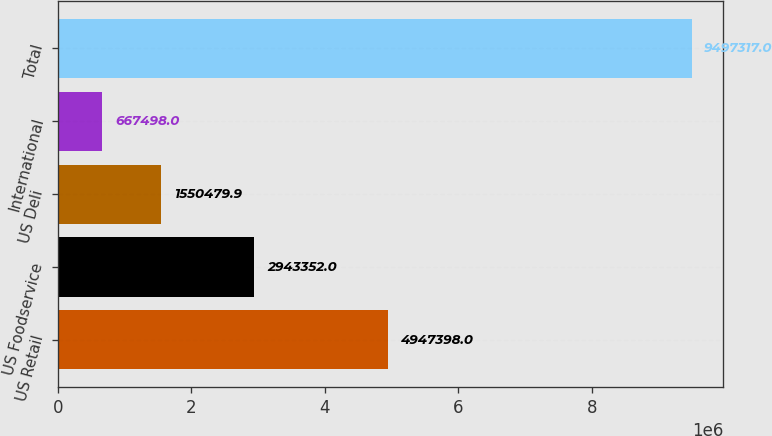Convert chart. <chart><loc_0><loc_0><loc_500><loc_500><bar_chart><fcel>US Retail<fcel>US Foodservice<fcel>US Deli<fcel>International<fcel>Total<nl><fcel>4.9474e+06<fcel>2.94335e+06<fcel>1.55048e+06<fcel>667498<fcel>9.49732e+06<nl></chart> 